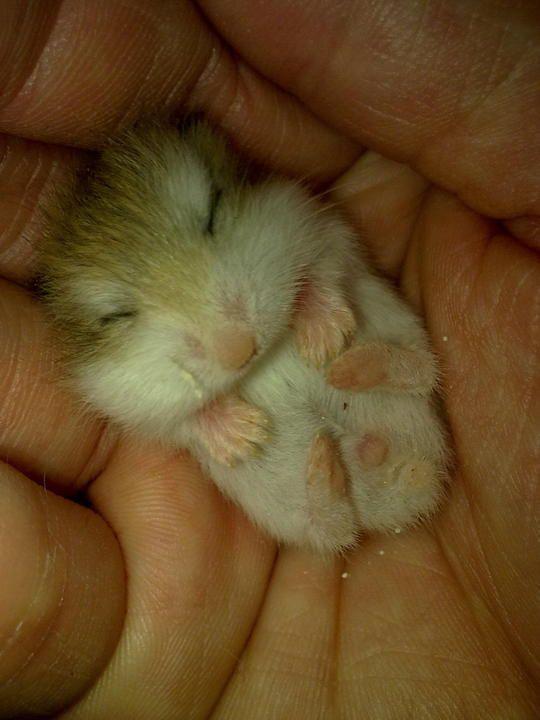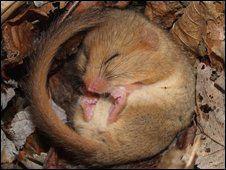The first image is the image on the left, the second image is the image on the right. For the images displayed, is the sentence "There is human hand carrying a hamster." factually correct? Answer yes or no. Yes. The first image is the image on the left, the second image is the image on the right. Analyze the images presented: Is the assertion "An image shows pet rodents inside a container with an opening at the front." valid? Answer yes or no. No. 